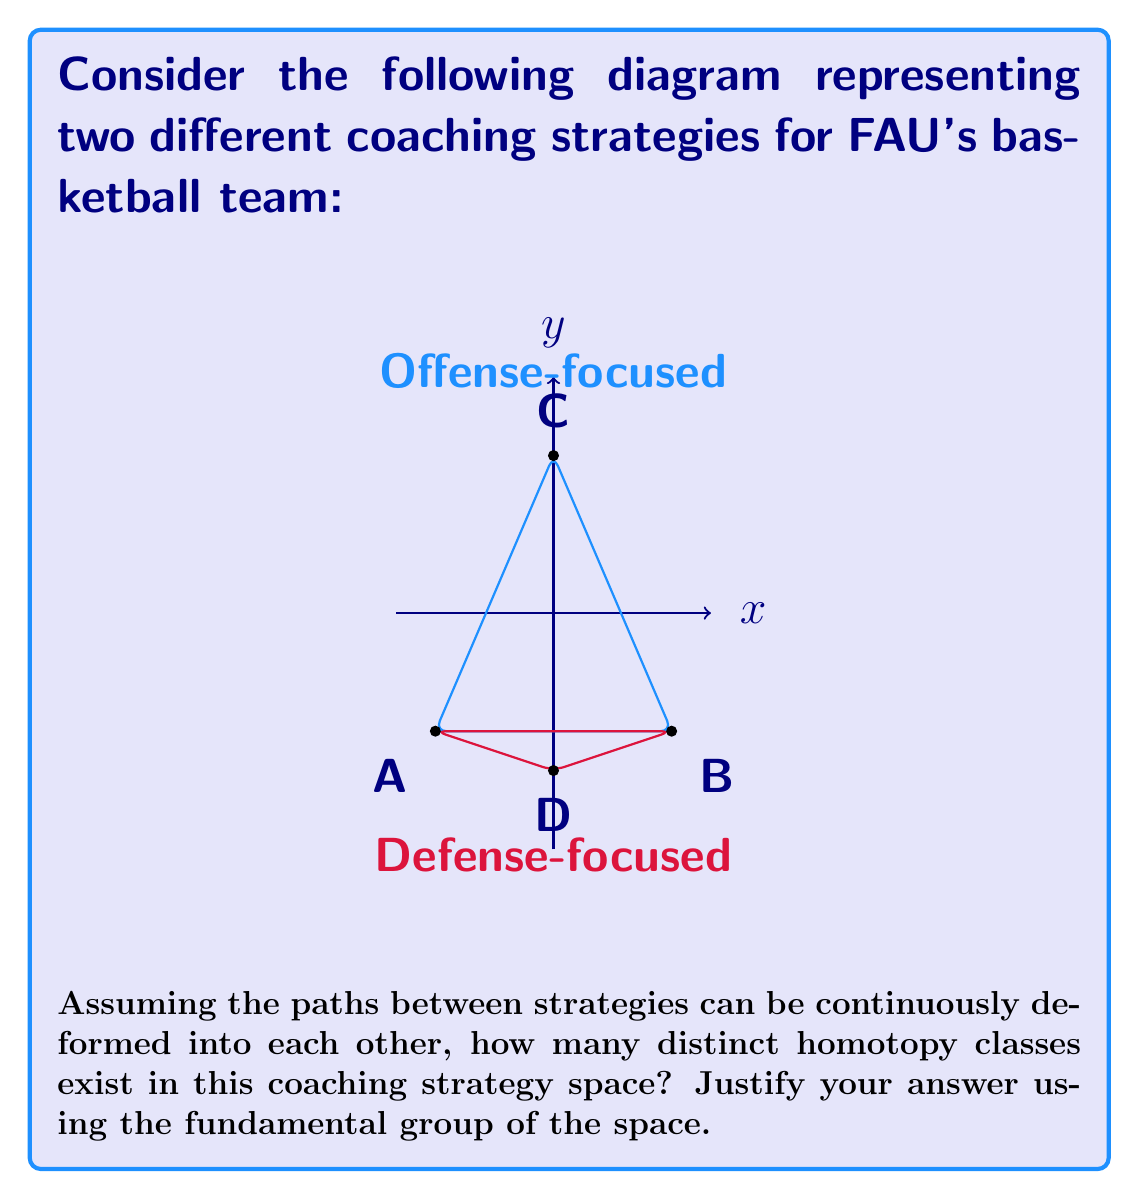Can you solve this math problem? To solve this problem, we need to analyze the topological structure of the coaching strategy space:

1. The diagram represents a simplicial complex with two triangles sharing a common edge (AB).

2. This structure is homotopy equivalent to a circle, as we can continuously deform the two triangles to a single loop.

3. The fundamental group of a circle is isomorphic to the integers under addition, denoted as $\pi_1(S^1) \cong \mathbb{Z}$.

4. Each integer in $\mathbb{Z}$ represents a distinct homotopy class of loops in the space.

5. Positive integers represent counterclockwise loops, negative integers represent clockwise loops, and 0 represents contractible loops.

6. Since there are infinitely many integers, there are infinitely many distinct homotopy classes in this coaching strategy space.

7. Intuitively, this means that a coach can "cycle" between offense-focused and defense-focused strategies any number of times, and each distinct number of cycles represents a different overall coaching approach.

8. The skepticism towards new hires is reflected in the fact that seemingly different strategies (represented by the two triangles) are fundamentally equivalent in terms of their topological structure.
Answer: $\infty$ (infinitely many) homotopy classes 